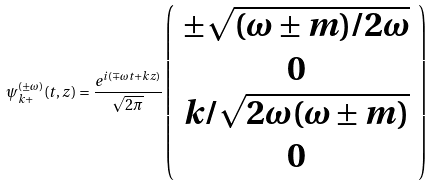<formula> <loc_0><loc_0><loc_500><loc_500>\psi ^ { ( \pm \omega ) } _ { k + } ( t , z ) = \frac { e ^ { i ( \mp \omega t + k z ) } } { \sqrt { 2 \pi } } \left ( \begin{array} { c } \pm \sqrt { ( \omega \pm m ) / 2 \omega } \\ 0 \\ k / \sqrt { 2 \omega ( \omega \pm m ) } \\ 0 \end{array} \right ) \,</formula> 